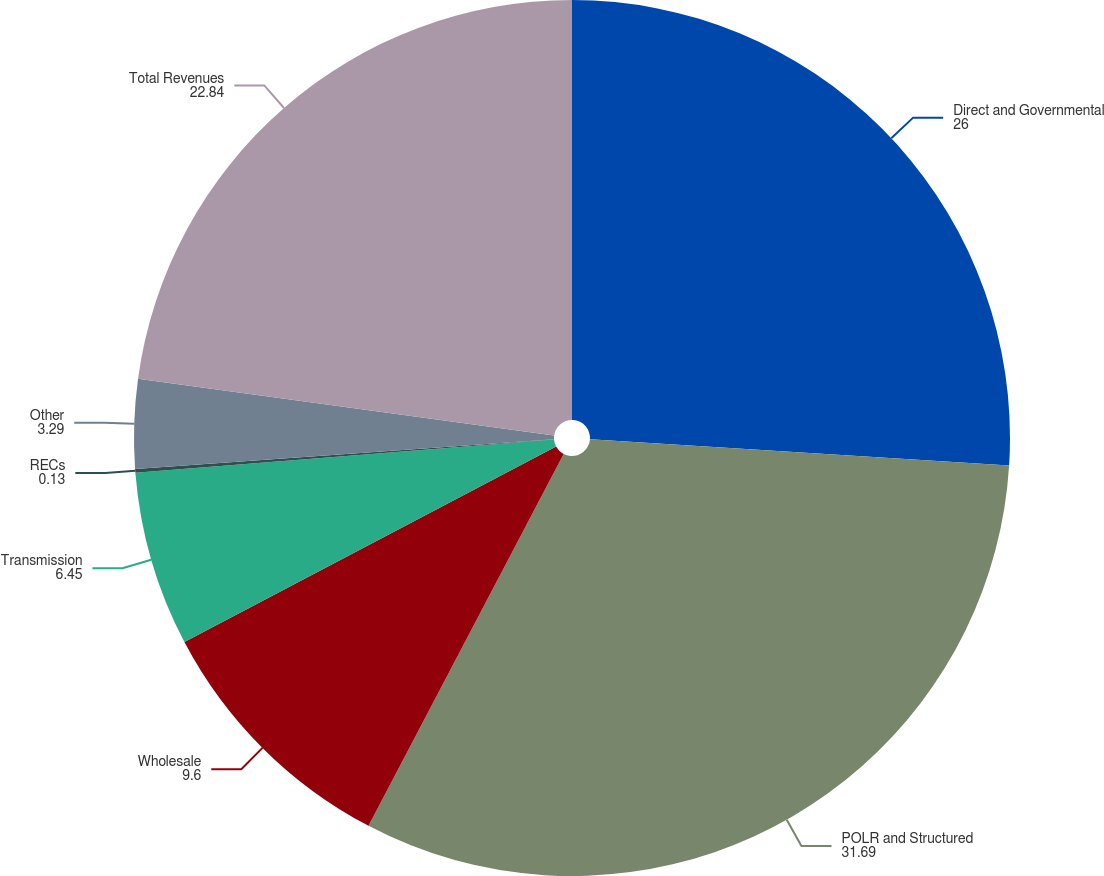Convert chart. <chart><loc_0><loc_0><loc_500><loc_500><pie_chart><fcel>Direct and Governmental<fcel>POLR and Structured<fcel>Wholesale<fcel>Transmission<fcel>RECs<fcel>Other<fcel>Total Revenues<nl><fcel>26.0%<fcel>31.69%<fcel>9.6%<fcel>6.45%<fcel>0.13%<fcel>3.29%<fcel>22.84%<nl></chart> 